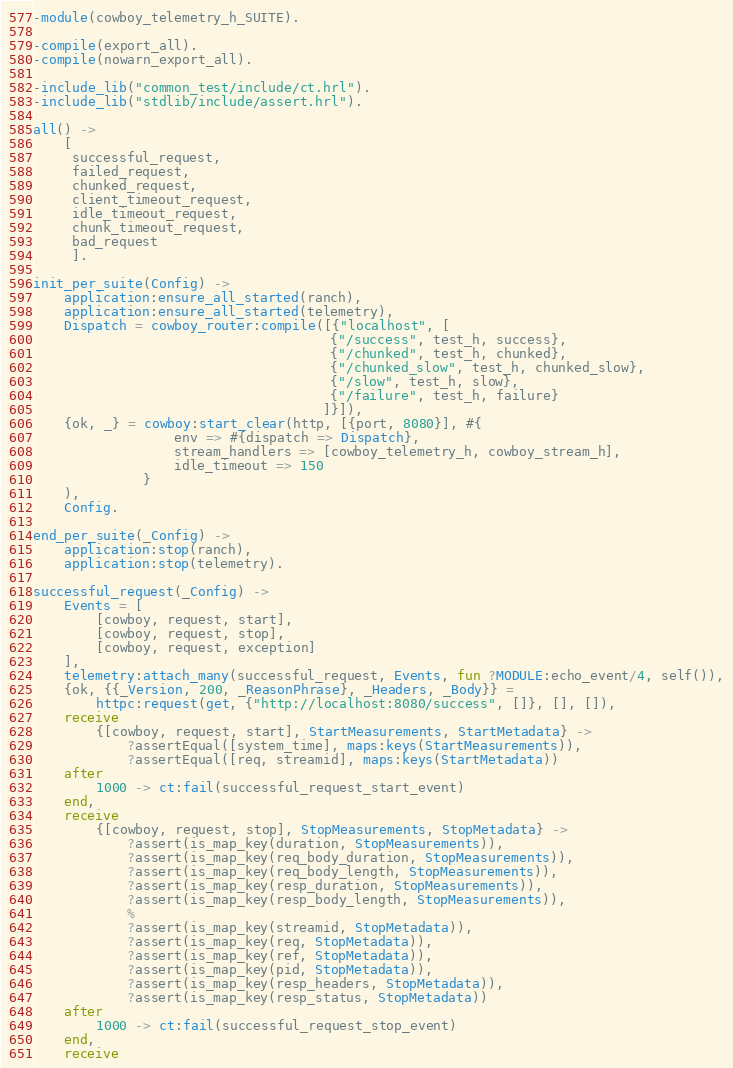Convert code to text. <code><loc_0><loc_0><loc_500><loc_500><_Erlang_>-module(cowboy_telemetry_h_SUITE).

-compile(export_all).
-compile(nowarn_export_all).

-include_lib("common_test/include/ct.hrl").
-include_lib("stdlib/include/assert.hrl").

all() ->
    [
     successful_request,
     failed_request,
     chunked_request,
     client_timeout_request,
     idle_timeout_request,
     chunk_timeout_request,
     bad_request
     ].

init_per_suite(Config) ->
    application:ensure_all_started(ranch),
    application:ensure_all_started(telemetry),
    Dispatch = cowboy_router:compile([{"localhost", [
                                      {"/success", test_h, success},
                                      {"/chunked", test_h, chunked},
                                      {"/chunked_slow", test_h, chunked_slow},
                                      {"/slow", test_h, slow},
                                      {"/failure", test_h, failure}
                                     ]}]),
    {ok, _} = cowboy:start_clear(http, [{port, 8080}], #{
                  env => #{dispatch => Dispatch},
                  stream_handlers => [cowboy_telemetry_h, cowboy_stream_h],
                  idle_timeout => 150
              }
    ),
    Config.

end_per_suite(_Config) ->
    application:stop(ranch),
    application:stop(telemetry).

successful_request(_Config) ->
    Events = [
        [cowboy, request, start],
        [cowboy, request, stop],
        [cowboy, request, exception]
    ],
    telemetry:attach_many(successful_request, Events, fun ?MODULE:echo_event/4, self()),
    {ok, {{_Version, 200, _ReasonPhrase}, _Headers, _Body}} =
        httpc:request(get, {"http://localhost:8080/success", []}, [], []),
    receive
        {[cowboy, request, start], StartMeasurements, StartMetadata} ->
            ?assertEqual([system_time], maps:keys(StartMeasurements)),
            ?assertEqual([req, streamid], maps:keys(StartMetadata))
    after
        1000 -> ct:fail(successful_request_start_event)
    end,
    receive
        {[cowboy, request, stop], StopMeasurements, StopMetadata} ->
            ?assert(is_map_key(duration, StopMeasurements)),
            ?assert(is_map_key(req_body_duration, StopMeasurements)),
            ?assert(is_map_key(req_body_length, StopMeasurements)),
            ?assert(is_map_key(resp_duration, StopMeasurements)),
            ?assert(is_map_key(resp_body_length, StopMeasurements)),
            %
            ?assert(is_map_key(streamid, StopMetadata)),
            ?assert(is_map_key(req, StopMetadata)),
            ?assert(is_map_key(ref, StopMetadata)),
            ?assert(is_map_key(pid, StopMetadata)),
            ?assert(is_map_key(resp_headers, StopMetadata)),
            ?assert(is_map_key(resp_status, StopMetadata))
    after
        1000 -> ct:fail(successful_request_stop_event)
    end,
    receive</code> 